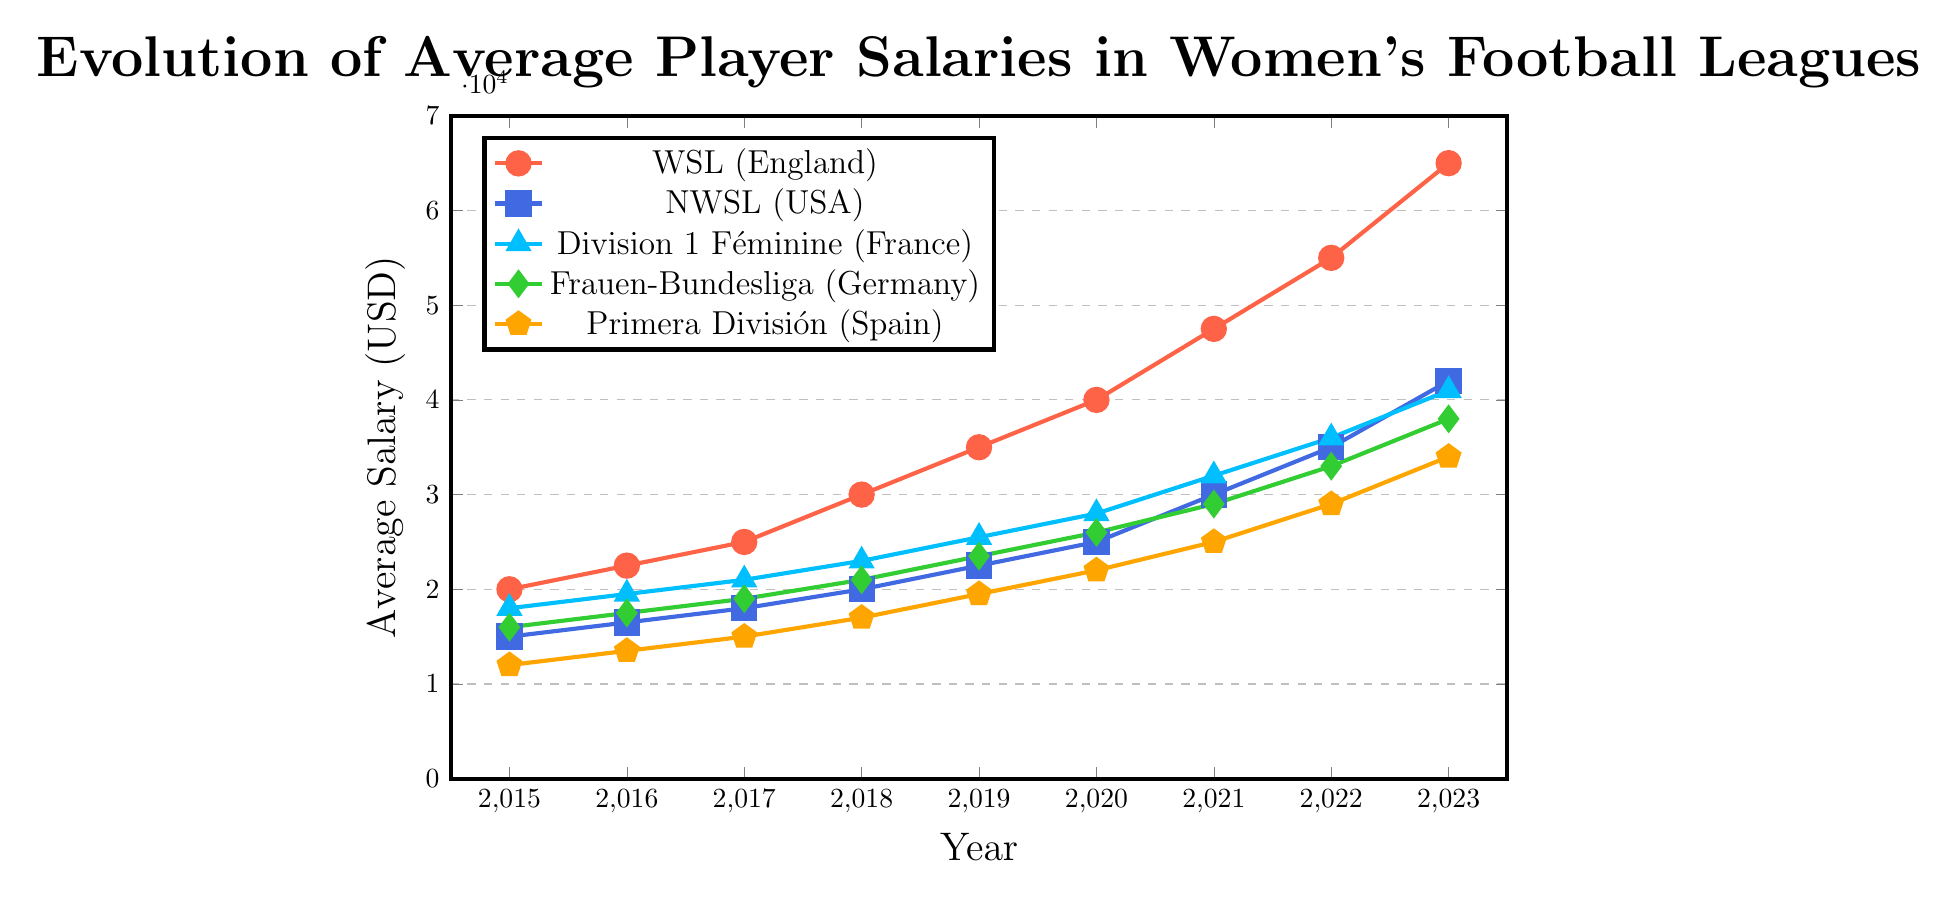Which league had the highest average player salary in 2023? In 2023, WSL (England) has an average salary of 65000, which is the highest among all leagues shown in the chart.
Answer: WSL (England) Between which two consecutive years did WSL (England) see the largest increase in average player salary? The largest increase in WSL (England)'s average salary happens between 2022 (55000) and 2023 (65000), showing a gain of 10000.
Answer: 2022 to 2023 How does the average salary of Division 1 Féminine (France) in 2018 compare to that of Frauen-Bundesliga (Germany) in the same year? In 2018, Division 1 Féminine (France) had an average salary of 23000, whereas Frauen-Bundesliga (Germany) had an average salary of 21000. Division 1 Féminine (France)'s salary is higher.
Answer: Division 1 Féminine (France) is higher What is the total average player salary increase for NWSL (USA) from 2015 to 2023? In 2015, the average salary for NWSL (USA) was 15000. By 2023, it increased to 42000. The total increase is 42000 - 15000 = 27000.
Answer: 27000 Which league showed the smallest increase in average player salary between 2020 and 2021? Between 2020 and 2021, NWSL (USA) increased from 25000 to 30000 (5000 increase), Division 1 Féminine (France) from 28000 to 32000 (4000 increase), Frauen-Bundesliga (Germany) from 26000 to 29000 (3000 increase), and Primera División (Spain) from 22000 to 25000 (3000 increase). The smallest increase is shared by Frauen-Bundesliga (Germany) and Primera División (Spain) with an increase of 3000 each.
Answer: Frauen-Bundesliga (Germany) and Primera División (Spain) What is the average salary of WSL (England) over the period from 2015 to 2023? The average salary of WSL (England) over these years is calculated by summing the salaries from 2015 to 2023 and dividing by the number of years. Sum = 20000 + 22500 + 25000 + 30000 + 35000 + 40000 + 47500 + 55000 + 65000 = 340000. Average = 340000 / 9 ≈ 37778.
Answer: 37778 In which year did Primera División (Spain) reach an average salary of 20000 or more? Primera División (Spain) reaches an average salary of 20000 in the year 2019 with a salary of 19500 which is just slightly below, and it officially surpasses 20000 in 2020 with a salary of 22000.
Answer: 2020 How does the average salary growth in Frauen-Bundesliga (Germany) from 2017 to 2023 compare to that in Division 1 Féminine (France)? Frauen-Bundesliga (Germany) grew from 19000 in 2017 to 38000 in 2023 (an increase of 19000), and Division 1 Féminine (France) grew from 21000 in 2017 to 41000 in 2023 (an increase of 20000). Division 1 Féminine had a slightly larger increase.
Answer: Division 1 Féminine (France) had a larger growth By how much did the average salary of NWSL (USA) increase from 2017 to 2018? In 2017, NWSL (USA) had an average salary of 18000, which increased to 20000 in 2018. The increase is 20000 - 18000 = 2000.
Answer: 2000 